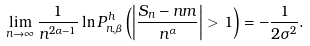<formula> <loc_0><loc_0><loc_500><loc_500>\lim _ { n \to \infty } \frac { 1 } { n ^ { 2 \alpha - 1 } } \ln P _ { n , \beta } ^ { h } \left ( \left | \frac { S _ { n } - n m } { n ^ { \alpha } } \right | > 1 \right ) = - \frac { 1 } { 2 \sigma ^ { 2 } } .</formula> 